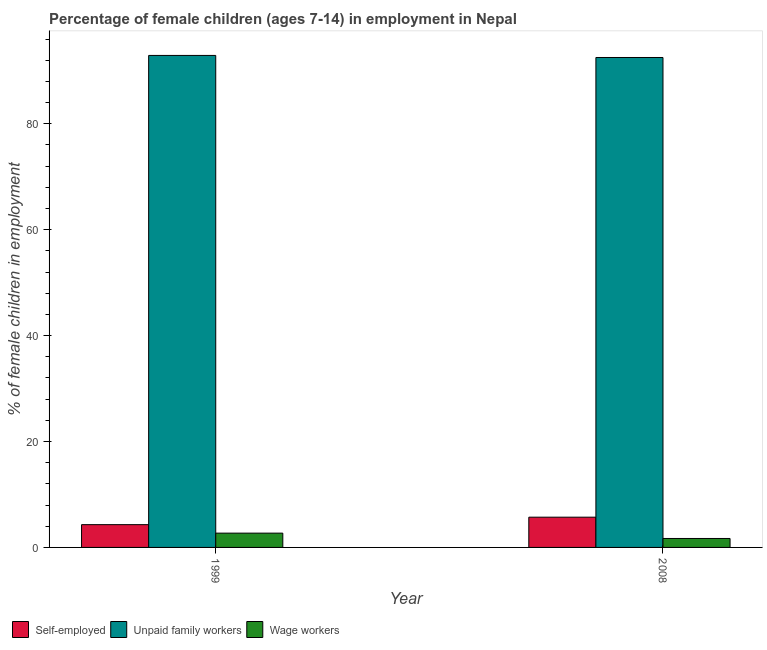How many different coloured bars are there?
Offer a terse response. 3. Are the number of bars on each tick of the X-axis equal?
Your answer should be very brief. Yes. What is the label of the 2nd group of bars from the left?
Provide a succinct answer. 2008. In how many cases, is the number of bars for a given year not equal to the number of legend labels?
Give a very brief answer. 0. What is the percentage of children employed as wage workers in 2008?
Ensure brevity in your answer.  1.69. Across all years, what is the maximum percentage of self employed children?
Offer a terse response. 5.71. Across all years, what is the minimum percentage of children employed as unpaid family workers?
Your answer should be very brief. 92.51. In which year was the percentage of children employed as unpaid family workers minimum?
Provide a succinct answer. 2008. What is the total percentage of children employed as wage workers in the graph?
Your response must be concise. 4.39. What is the difference between the percentage of children employed as unpaid family workers in 1999 and that in 2008?
Your answer should be compact. 0.39. What is the difference between the percentage of self employed children in 1999 and the percentage of children employed as unpaid family workers in 2008?
Offer a very short reply. -1.41. What is the average percentage of self employed children per year?
Offer a very short reply. 5. In how many years, is the percentage of self employed children greater than 68 %?
Your response must be concise. 0. What is the ratio of the percentage of children employed as unpaid family workers in 1999 to that in 2008?
Provide a succinct answer. 1. What does the 2nd bar from the left in 1999 represents?
Provide a succinct answer. Unpaid family workers. What does the 1st bar from the right in 1999 represents?
Give a very brief answer. Wage workers. Is it the case that in every year, the sum of the percentage of self employed children and percentage of children employed as unpaid family workers is greater than the percentage of children employed as wage workers?
Offer a very short reply. Yes. How many bars are there?
Keep it short and to the point. 6. Are all the bars in the graph horizontal?
Your answer should be very brief. No. How many years are there in the graph?
Keep it short and to the point. 2. What is the difference between two consecutive major ticks on the Y-axis?
Your response must be concise. 20. Are the values on the major ticks of Y-axis written in scientific E-notation?
Your answer should be compact. No. Does the graph contain any zero values?
Keep it short and to the point. No. Does the graph contain grids?
Offer a very short reply. No. What is the title of the graph?
Provide a short and direct response. Percentage of female children (ages 7-14) in employment in Nepal. What is the label or title of the X-axis?
Make the answer very short. Year. What is the label or title of the Y-axis?
Your answer should be very brief. % of female children in employment. What is the % of female children in employment in Self-employed in 1999?
Offer a very short reply. 4.3. What is the % of female children in employment of Unpaid family workers in 1999?
Provide a short and direct response. 92.9. What is the % of female children in employment in Wage workers in 1999?
Offer a terse response. 2.7. What is the % of female children in employment of Self-employed in 2008?
Offer a very short reply. 5.71. What is the % of female children in employment of Unpaid family workers in 2008?
Provide a succinct answer. 92.51. What is the % of female children in employment in Wage workers in 2008?
Make the answer very short. 1.69. Across all years, what is the maximum % of female children in employment in Self-employed?
Keep it short and to the point. 5.71. Across all years, what is the maximum % of female children in employment of Unpaid family workers?
Provide a succinct answer. 92.9. Across all years, what is the maximum % of female children in employment in Wage workers?
Your response must be concise. 2.7. Across all years, what is the minimum % of female children in employment of Unpaid family workers?
Keep it short and to the point. 92.51. Across all years, what is the minimum % of female children in employment in Wage workers?
Offer a terse response. 1.69. What is the total % of female children in employment in Self-employed in the graph?
Offer a very short reply. 10.01. What is the total % of female children in employment in Unpaid family workers in the graph?
Your answer should be compact. 185.41. What is the total % of female children in employment in Wage workers in the graph?
Your response must be concise. 4.39. What is the difference between the % of female children in employment in Self-employed in 1999 and that in 2008?
Your answer should be very brief. -1.41. What is the difference between the % of female children in employment of Unpaid family workers in 1999 and that in 2008?
Your answer should be compact. 0.39. What is the difference between the % of female children in employment in Self-employed in 1999 and the % of female children in employment in Unpaid family workers in 2008?
Offer a terse response. -88.21. What is the difference between the % of female children in employment of Self-employed in 1999 and the % of female children in employment of Wage workers in 2008?
Provide a succinct answer. 2.61. What is the difference between the % of female children in employment of Unpaid family workers in 1999 and the % of female children in employment of Wage workers in 2008?
Offer a terse response. 91.21. What is the average % of female children in employment in Self-employed per year?
Provide a short and direct response. 5. What is the average % of female children in employment of Unpaid family workers per year?
Your response must be concise. 92.7. What is the average % of female children in employment in Wage workers per year?
Give a very brief answer. 2.19. In the year 1999, what is the difference between the % of female children in employment in Self-employed and % of female children in employment in Unpaid family workers?
Your answer should be very brief. -88.6. In the year 1999, what is the difference between the % of female children in employment of Unpaid family workers and % of female children in employment of Wage workers?
Ensure brevity in your answer.  90.2. In the year 2008, what is the difference between the % of female children in employment of Self-employed and % of female children in employment of Unpaid family workers?
Offer a very short reply. -86.8. In the year 2008, what is the difference between the % of female children in employment of Self-employed and % of female children in employment of Wage workers?
Keep it short and to the point. 4.02. In the year 2008, what is the difference between the % of female children in employment in Unpaid family workers and % of female children in employment in Wage workers?
Your response must be concise. 90.82. What is the ratio of the % of female children in employment of Self-employed in 1999 to that in 2008?
Your response must be concise. 0.75. What is the ratio of the % of female children in employment of Wage workers in 1999 to that in 2008?
Offer a terse response. 1.6. What is the difference between the highest and the second highest % of female children in employment in Self-employed?
Your answer should be very brief. 1.41. What is the difference between the highest and the second highest % of female children in employment in Unpaid family workers?
Make the answer very short. 0.39. What is the difference between the highest and the second highest % of female children in employment in Wage workers?
Your response must be concise. 1.01. What is the difference between the highest and the lowest % of female children in employment in Self-employed?
Offer a terse response. 1.41. What is the difference between the highest and the lowest % of female children in employment in Unpaid family workers?
Offer a terse response. 0.39. What is the difference between the highest and the lowest % of female children in employment of Wage workers?
Keep it short and to the point. 1.01. 